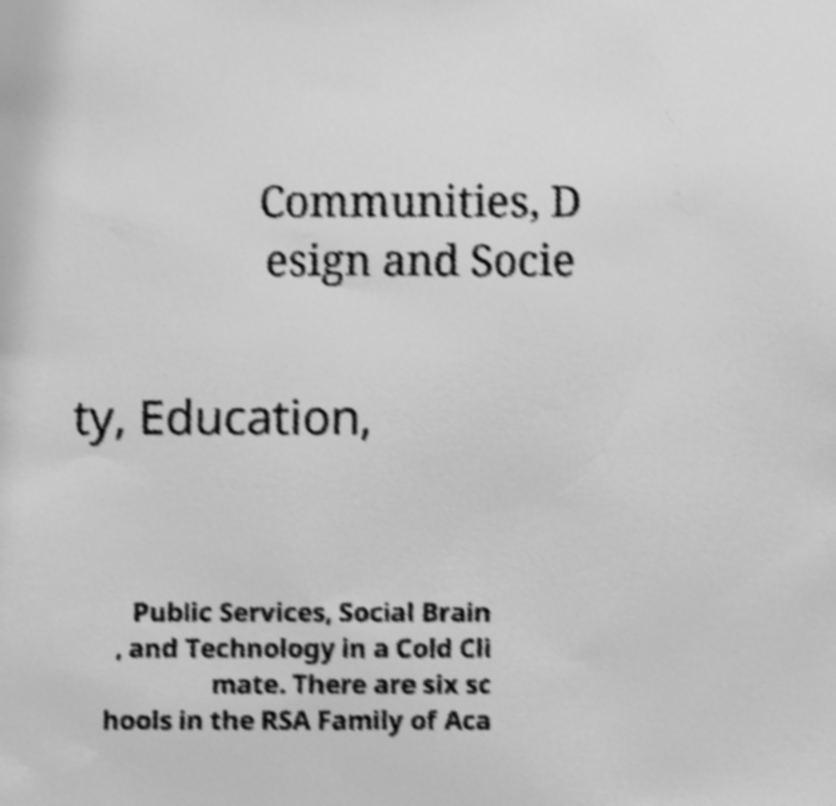Can you accurately transcribe the text from the provided image for me? Communities, D esign and Socie ty, Education, Public Services, Social Brain , and Technology in a Cold Cli mate. There are six sc hools in the RSA Family of Aca 